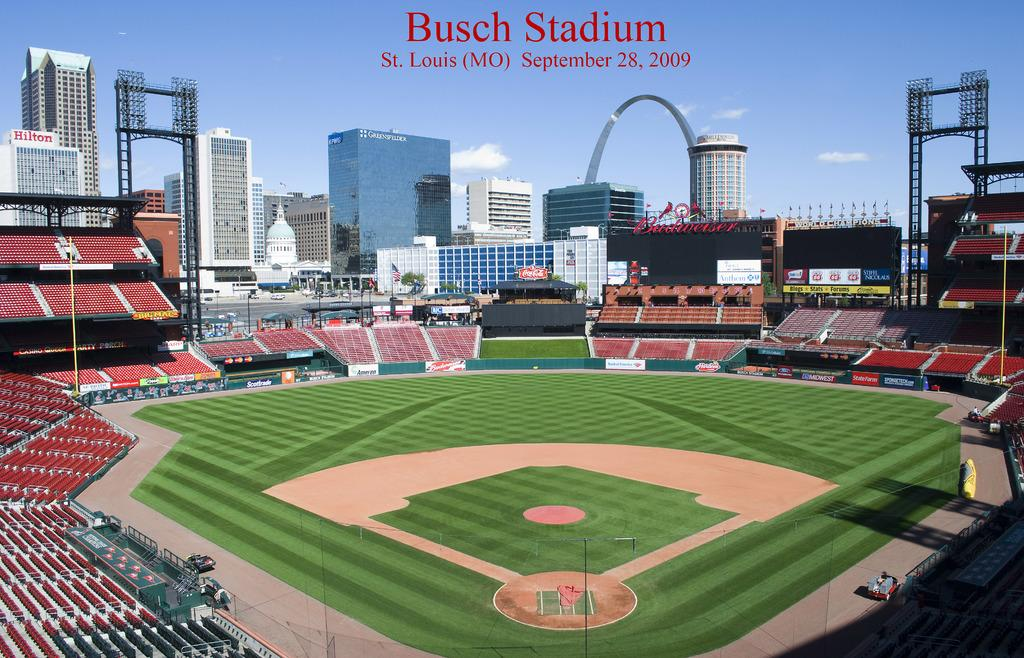<image>
Create a compact narrative representing the image presented. A picture of an empty Busch Stadium on September 28 2009 